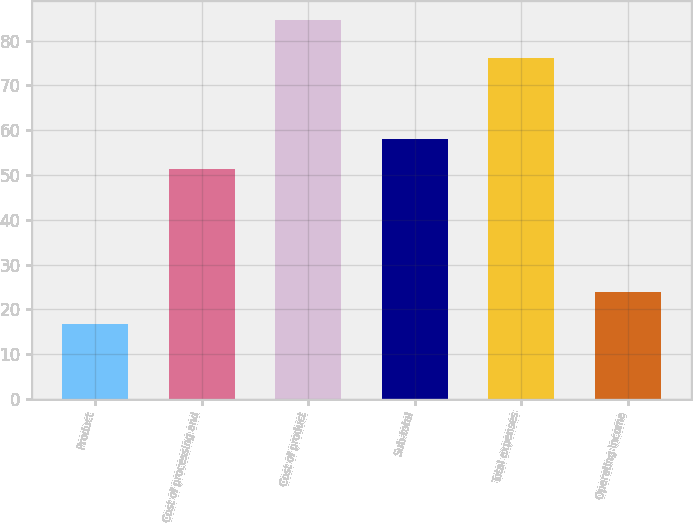<chart> <loc_0><loc_0><loc_500><loc_500><bar_chart><fcel>Product<fcel>Cost of processing and<fcel>Cost of product<fcel>Sub-total<fcel>Total expenses<fcel>Operating income<nl><fcel>16.7<fcel>51.3<fcel>84.7<fcel>58.1<fcel>76.1<fcel>23.9<nl></chart> 